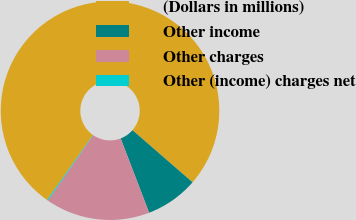<chart> <loc_0><loc_0><loc_500><loc_500><pie_chart><fcel>(Dollars in millions)<fcel>Other income<fcel>Other charges<fcel>Other (income) charges net<nl><fcel>76.61%<fcel>7.8%<fcel>15.44%<fcel>0.15%<nl></chart> 